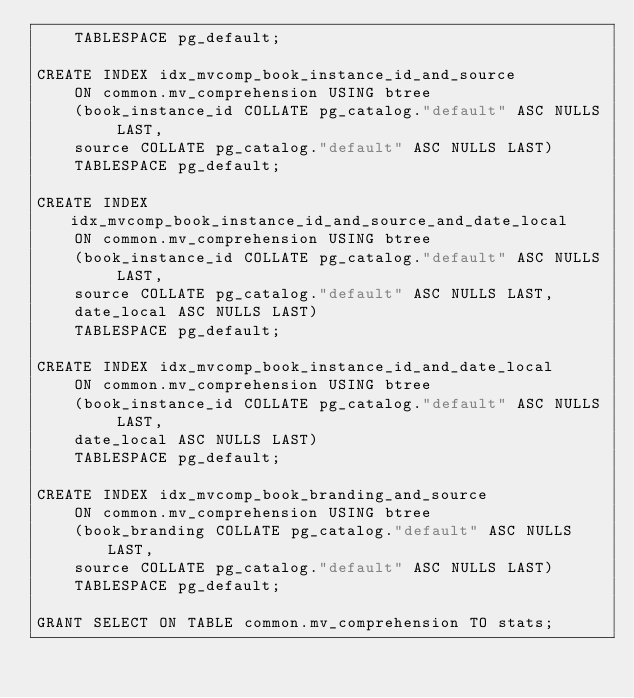Convert code to text. <code><loc_0><loc_0><loc_500><loc_500><_SQL_>    TABLESPACE pg_default;

CREATE INDEX idx_mvcomp_book_instance_id_and_source
    ON common.mv_comprehension USING btree
    (book_instance_id COLLATE pg_catalog."default" ASC NULLS LAST, 
    source COLLATE pg_catalog."default" ASC NULLS LAST)
    TABLESPACE pg_default;

CREATE INDEX idx_mvcomp_book_instance_id_and_source_and_date_local
    ON common.mv_comprehension USING btree
    (book_instance_id COLLATE pg_catalog."default" ASC NULLS LAST, 
    source COLLATE pg_catalog."default" ASC NULLS LAST, 
    date_local ASC NULLS LAST)
    TABLESPACE pg_default;

CREATE INDEX idx_mvcomp_book_instance_id_and_date_local
    ON common.mv_comprehension USING btree
    (book_instance_id COLLATE pg_catalog."default" ASC NULLS LAST, 
    date_local ASC NULLS LAST)
    TABLESPACE pg_default;

CREATE INDEX idx_mvcomp_book_branding_and_source
    ON common.mv_comprehension USING btree
    (book_branding COLLATE pg_catalog."default" ASC NULLS LAST, 
    source COLLATE pg_catalog."default" ASC NULLS LAST)
    TABLESPACE pg_default;

GRANT SELECT ON TABLE common.mv_comprehension TO stats;</code> 